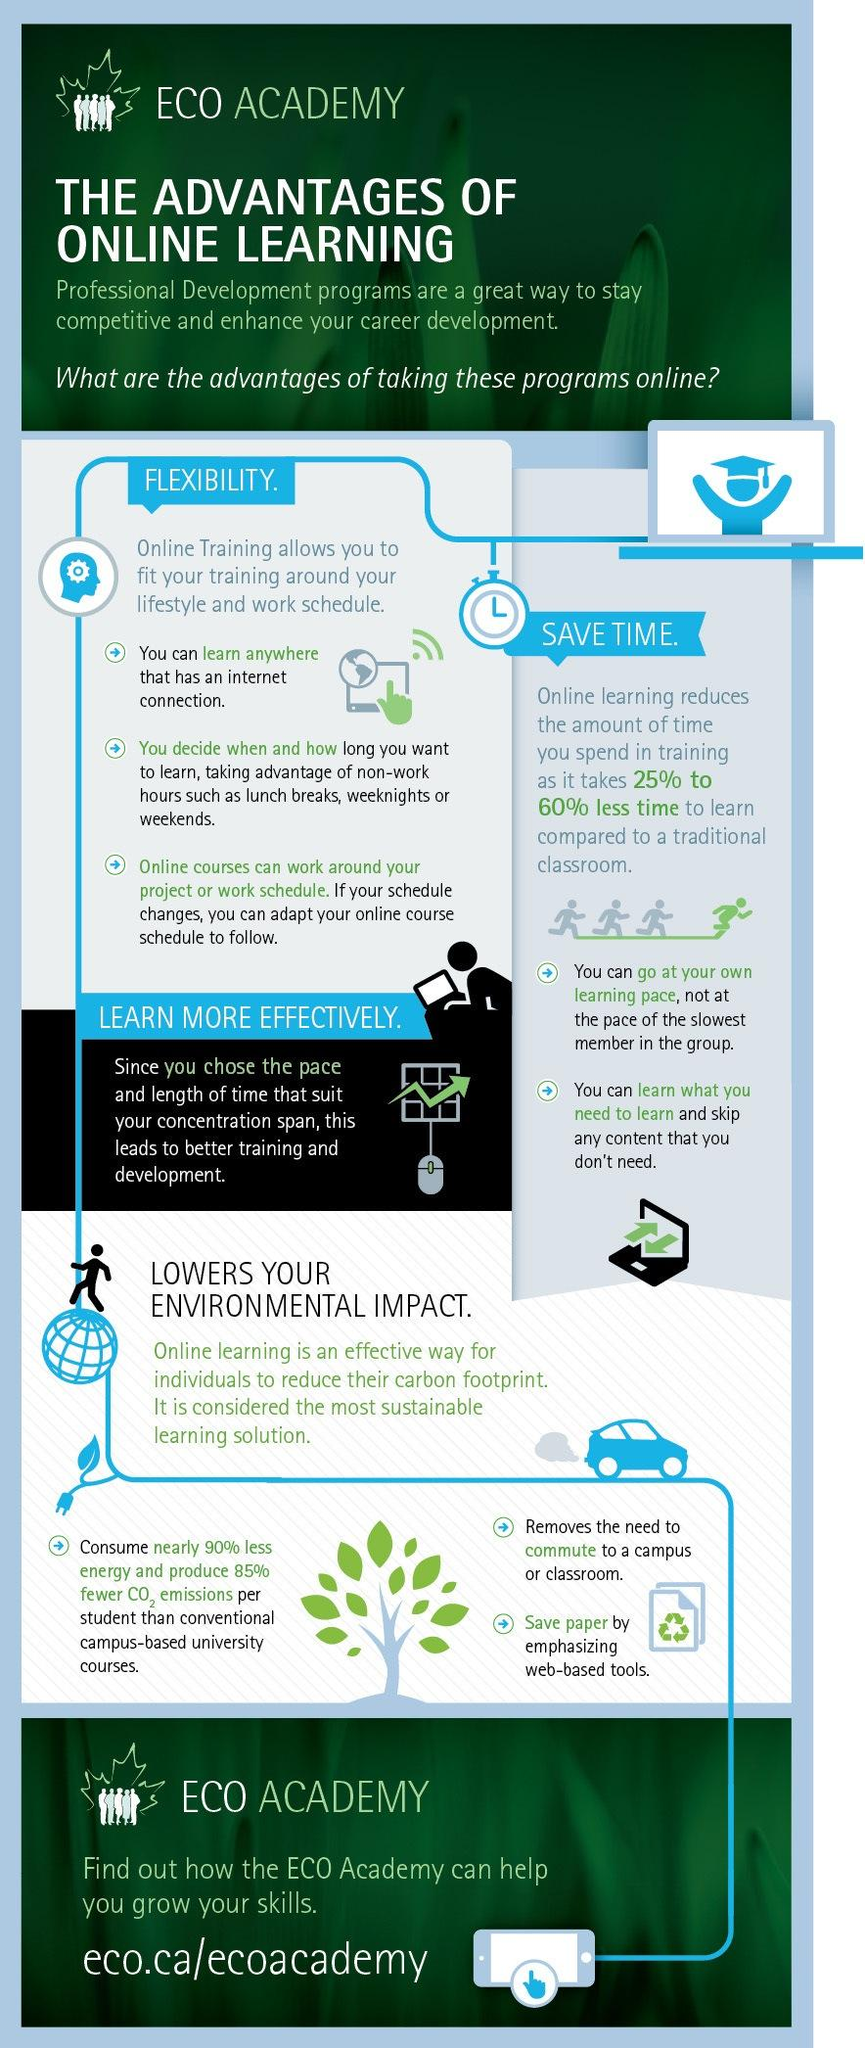List a handful of essential elements in this visual. Online learning provides students with numerous advantages, including 4. Online learning can save anywhere from 80% to 85% of the time compared to traditional classroom-based learning, while 25% to 60% of the time can be saved with online learning. However, online learning can save up to 85% to 90% of the time. 